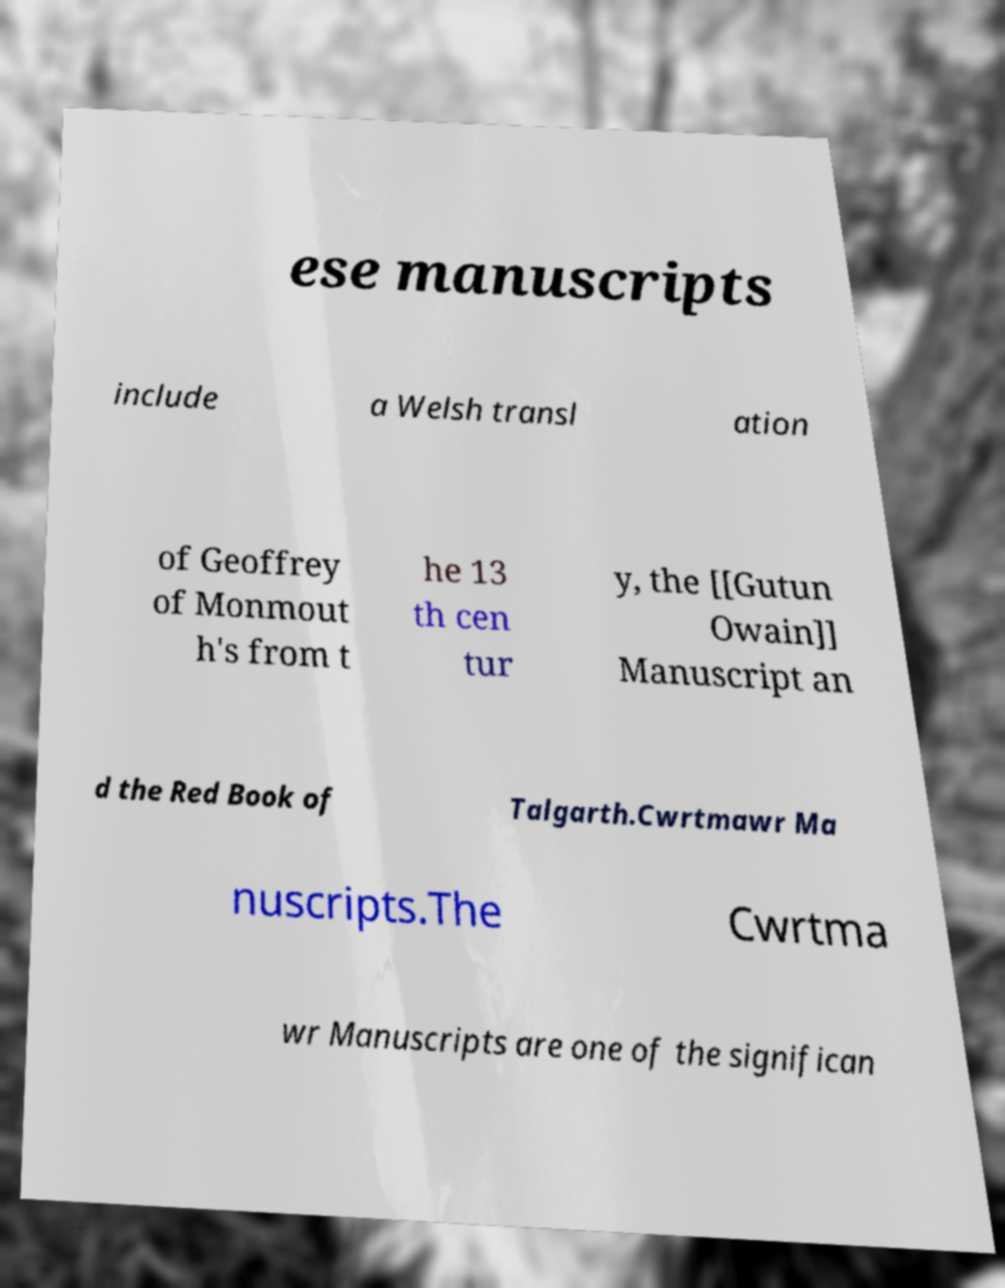Please read and relay the text visible in this image. What does it say? ese manuscripts include a Welsh transl ation of Geoffrey of Monmout h's from t he 13 th cen tur y, the [[Gutun Owain]] Manuscript an d the Red Book of Talgarth.Cwrtmawr Ma nuscripts.The Cwrtma wr Manuscripts are one of the significan 